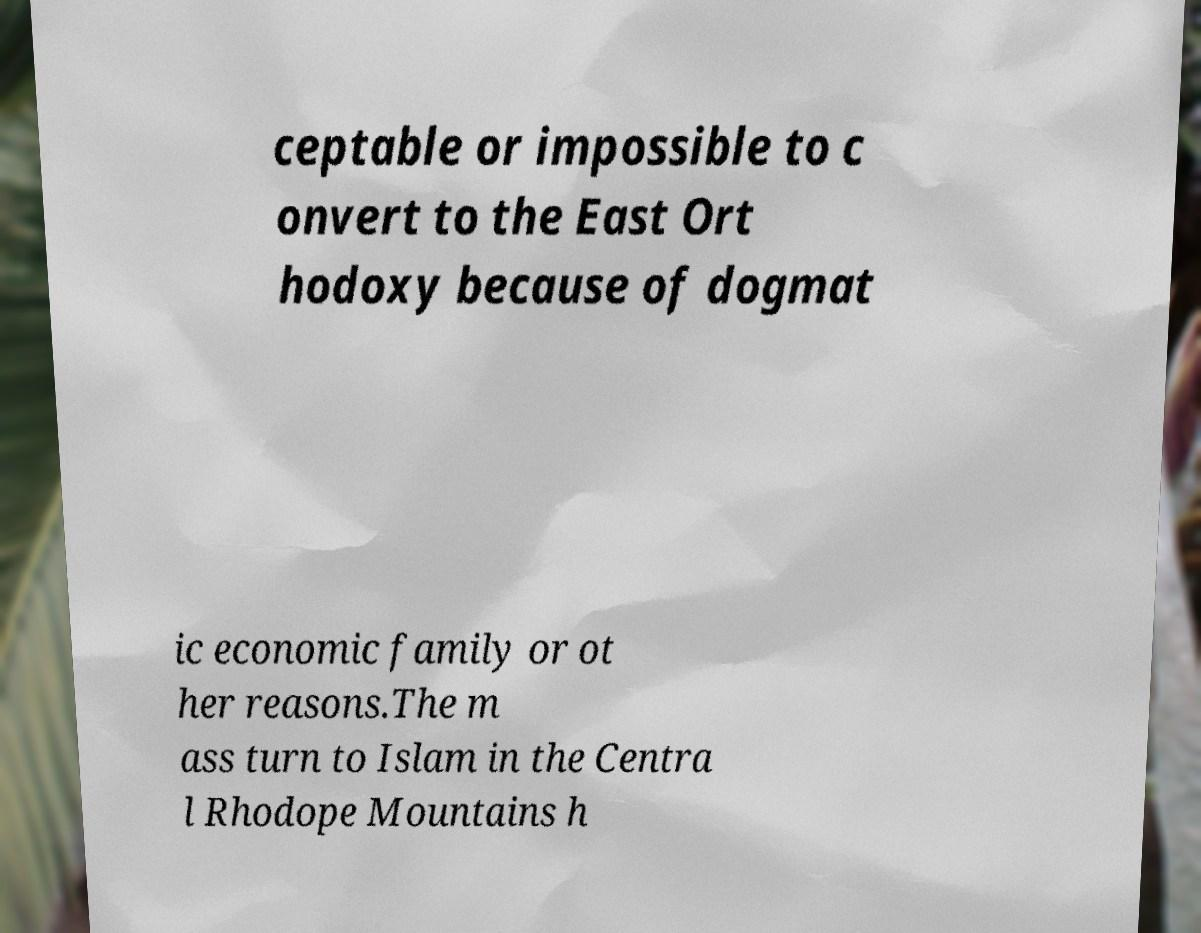Can you read and provide the text displayed in the image?This photo seems to have some interesting text. Can you extract and type it out for me? ceptable or impossible to c onvert to the East Ort hodoxy because of dogmat ic economic family or ot her reasons.The m ass turn to Islam in the Centra l Rhodope Mountains h 